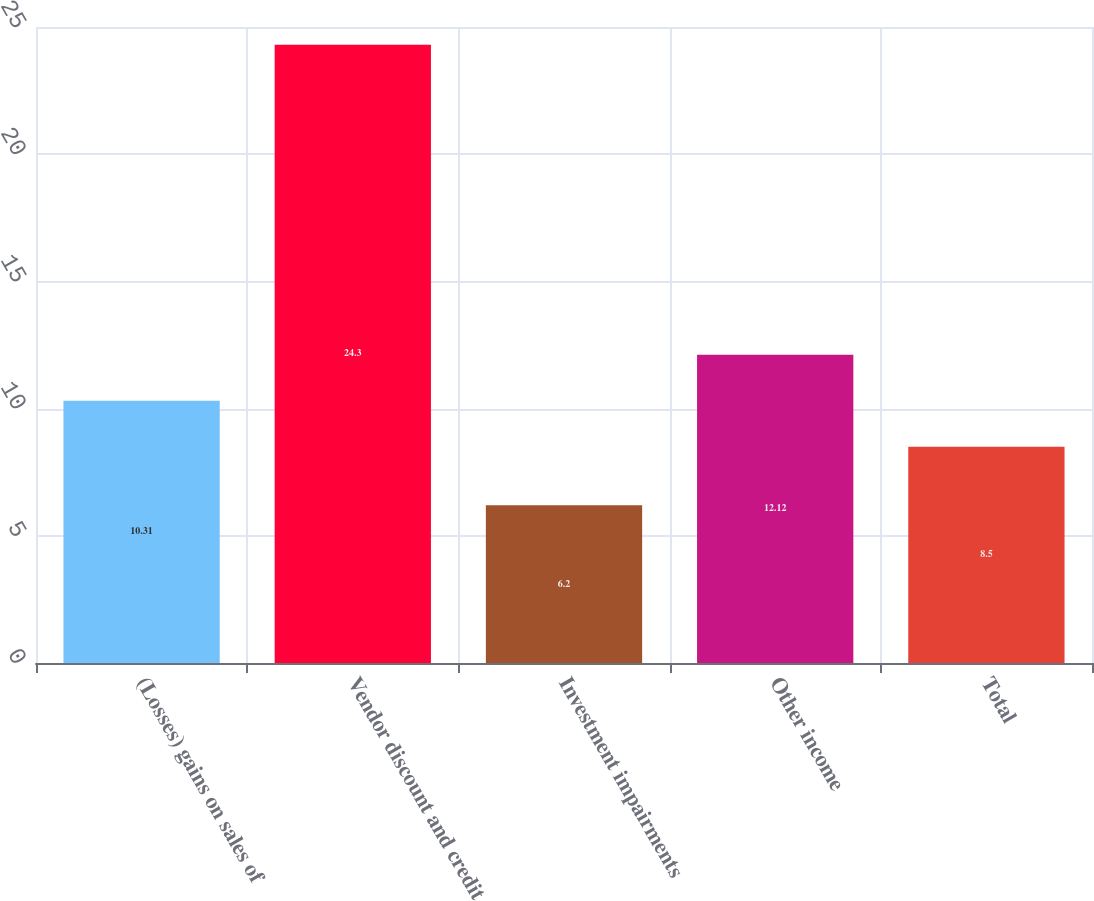<chart> <loc_0><loc_0><loc_500><loc_500><bar_chart><fcel>(Losses) gains on sales of<fcel>Vendor discount and credit<fcel>Investment impairments<fcel>Other income<fcel>Total<nl><fcel>10.31<fcel>24.3<fcel>6.2<fcel>12.12<fcel>8.5<nl></chart> 